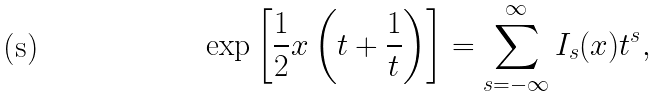<formula> <loc_0><loc_0><loc_500><loc_500>\exp \left [ { \frac { 1 } { 2 } } x \left ( t + \frac { 1 } { t } \right ) \right ] = \sum _ { s = - \infty } ^ { \infty } I _ { s } ( x ) t ^ { s } ,</formula> 